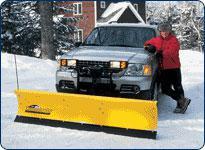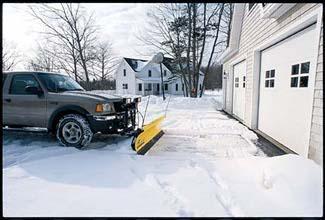The first image is the image on the left, the second image is the image on the right. Considering the images on both sides, is "Each image shows one gray truck equipped with a bright yellow snow plow and parked on snowy ground." valid? Answer yes or no. Yes. The first image is the image on the left, the second image is the image on the right. For the images shown, is this caption "A blue vehicle is pushing a yellow plow in the image on the left." true? Answer yes or no. No. 